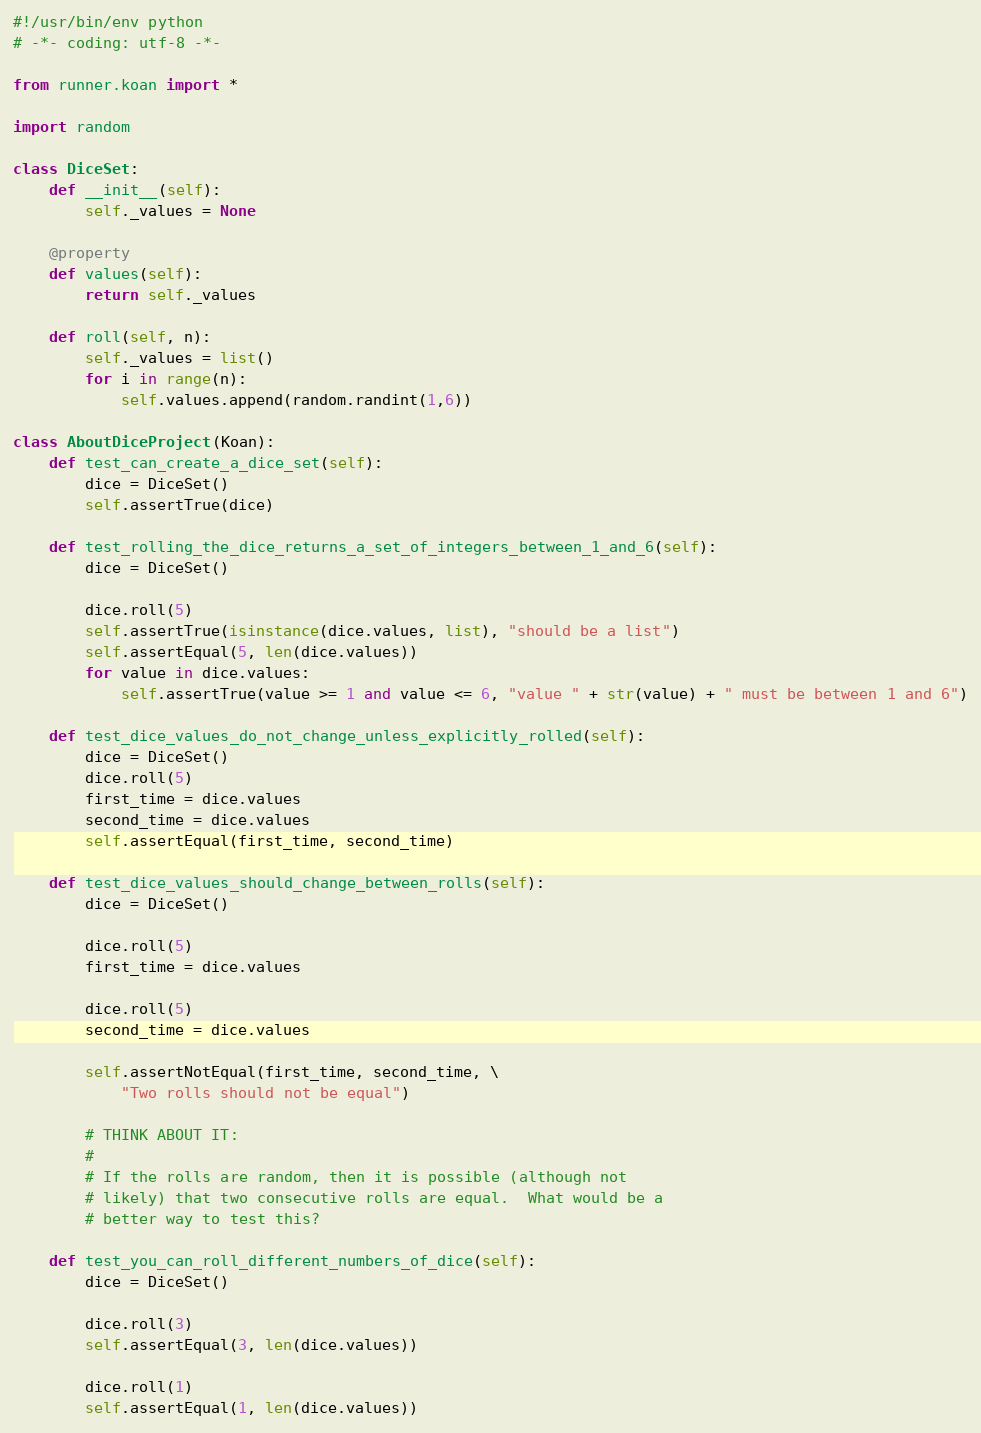<code> <loc_0><loc_0><loc_500><loc_500><_Python_>#!/usr/bin/env python
# -*- coding: utf-8 -*-

from runner.koan import *

import random

class DiceSet:
    def __init__(self):
        self._values = None

    @property
    def values(self):
        return self._values

    def roll(self, n):
        self._values = list()
        for i in range(n):
            self.values.append(random.randint(1,6))

class AboutDiceProject(Koan):
    def test_can_create_a_dice_set(self):
        dice = DiceSet()
        self.assertTrue(dice)

    def test_rolling_the_dice_returns_a_set_of_integers_between_1_and_6(self):
        dice = DiceSet()

        dice.roll(5)
        self.assertTrue(isinstance(dice.values, list), "should be a list")
        self.assertEqual(5, len(dice.values))
        for value in dice.values:
            self.assertTrue(value >= 1 and value <= 6, "value " + str(value) + " must be between 1 and 6")

    def test_dice_values_do_not_change_unless_explicitly_rolled(self):
        dice = DiceSet()
        dice.roll(5)
        first_time = dice.values
        second_time = dice.values
        self.assertEqual(first_time, second_time)

    def test_dice_values_should_change_between_rolls(self):
        dice = DiceSet()

        dice.roll(5)
        first_time = dice.values

        dice.roll(5)
        second_time = dice.values

        self.assertNotEqual(first_time, second_time, \
            "Two rolls should not be equal")

        # THINK ABOUT IT:
        #
        # If the rolls are random, then it is possible (although not
        # likely) that two consecutive rolls are equal.  What would be a
        # better way to test this?

    def test_you_can_roll_different_numbers_of_dice(self):
        dice = DiceSet()

        dice.roll(3)
        self.assertEqual(3, len(dice.values))

        dice.roll(1)
        self.assertEqual(1, len(dice.values))
</code> 